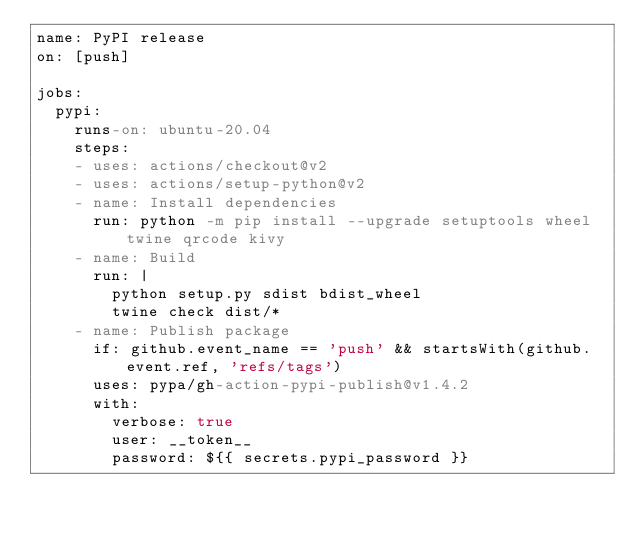Convert code to text. <code><loc_0><loc_0><loc_500><loc_500><_YAML_>name: PyPI release
on: [push]

jobs:
  pypi:
    runs-on: ubuntu-20.04
    steps:
    - uses: actions/checkout@v2
    - uses: actions/setup-python@v2
    - name: Install dependencies
      run: python -m pip install --upgrade setuptools wheel twine qrcode kivy
    - name: Build
      run: |
        python setup.py sdist bdist_wheel
        twine check dist/*
    - name: Publish package
      if: github.event_name == 'push' && startsWith(github.event.ref, 'refs/tags')
      uses: pypa/gh-action-pypi-publish@v1.4.2
      with:
        verbose: true
        user: __token__
        password: ${{ secrets.pypi_password }}
</code> 